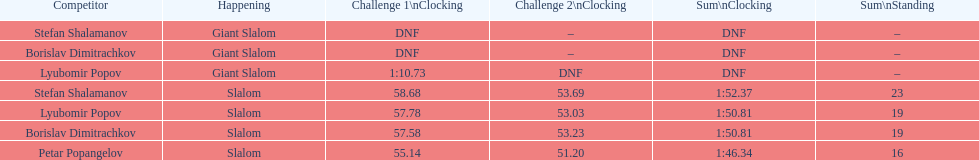Which athletes had consecutive times under 58 for both races? Lyubomir Popov, Borislav Dimitrachkov, Petar Popangelov. 